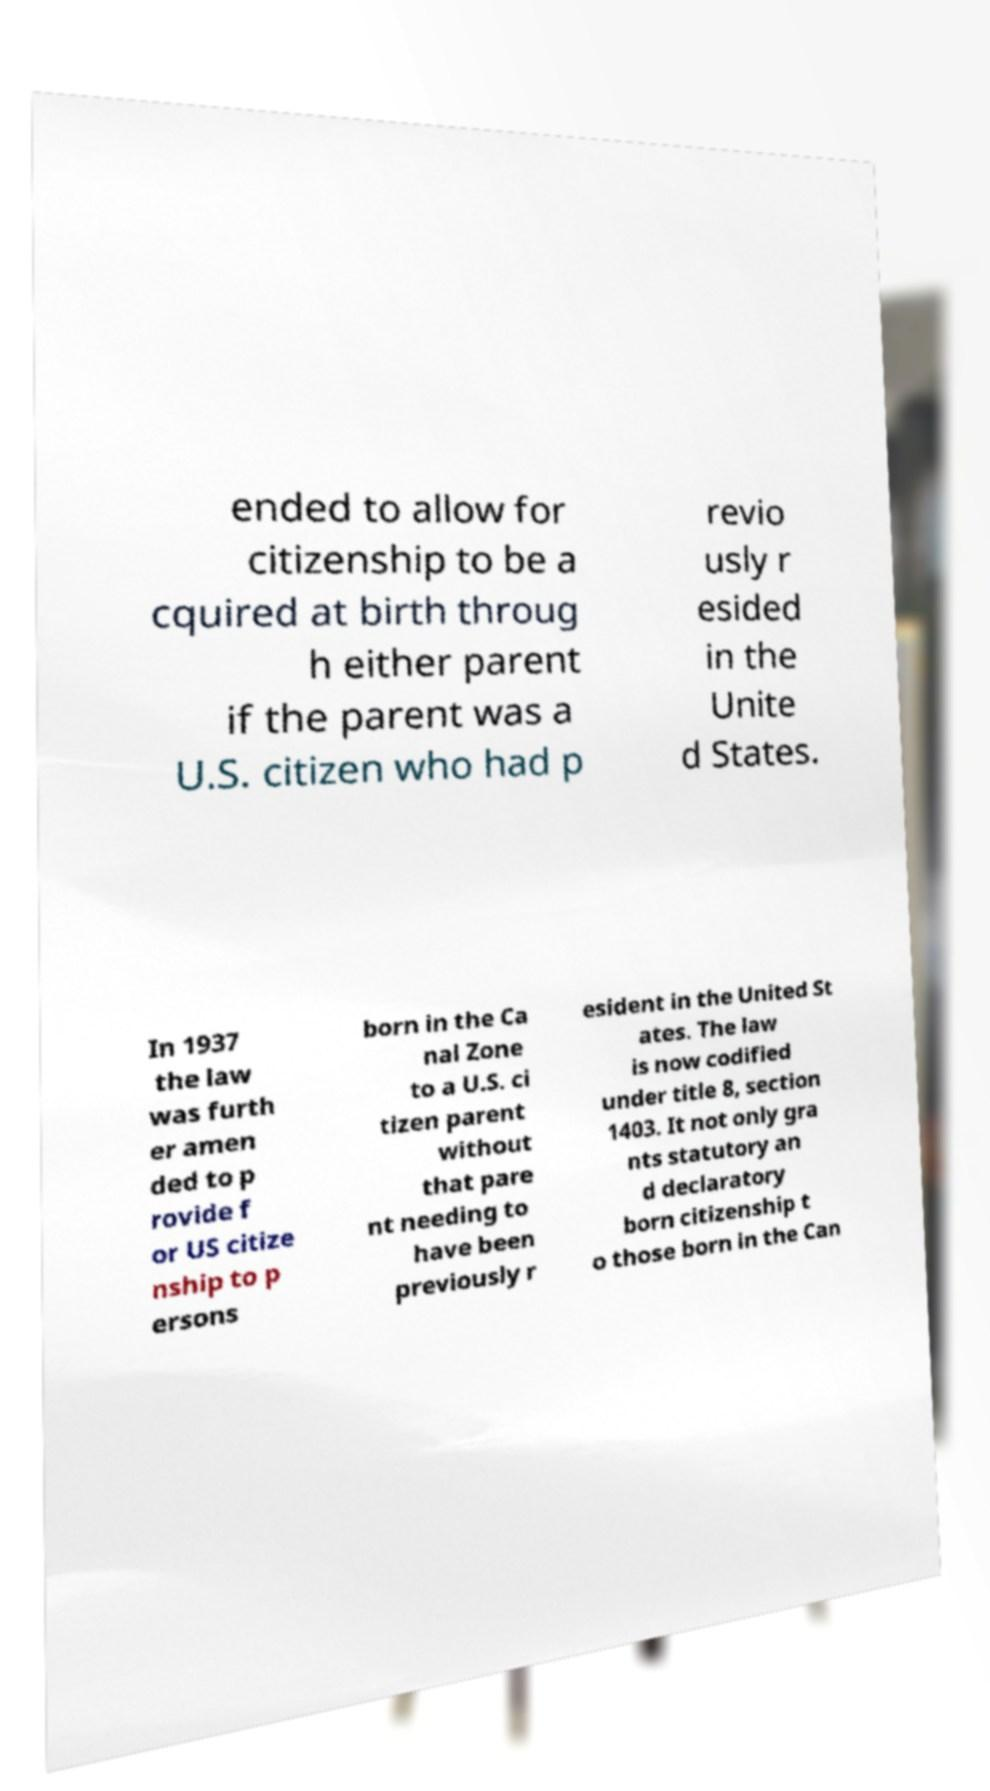I need the written content from this picture converted into text. Can you do that? ended to allow for citizenship to be a cquired at birth throug h either parent if the parent was a U.S. citizen who had p revio usly r esided in the Unite d States. In 1937 the law was furth er amen ded to p rovide f or US citize nship to p ersons born in the Ca nal Zone to a U.S. ci tizen parent without that pare nt needing to have been previously r esident in the United St ates. The law is now codified under title 8, section 1403. It not only gra nts statutory an d declaratory born citizenship t o those born in the Can 